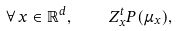Convert formula to latex. <formula><loc_0><loc_0><loc_500><loc_500>\forall \, x \in \mathbb { R } ^ { d } , \quad Z _ { x } ^ { t } P ( \mu _ { x } ) ,</formula> 